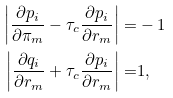<formula> <loc_0><loc_0><loc_500><loc_500>\left | \frac { \partial p _ { i } } { \partial \pi _ { m } } - \tau _ { c } \frac { \partial p _ { i } } { \partial r _ { m } } \right | = & - 1 \\ \left | \frac { \partial q _ { i } } { \partial r _ { m } } + \tau _ { c } \frac { \partial p _ { i } } { \partial r _ { m } } \right | = & 1 ,</formula> 